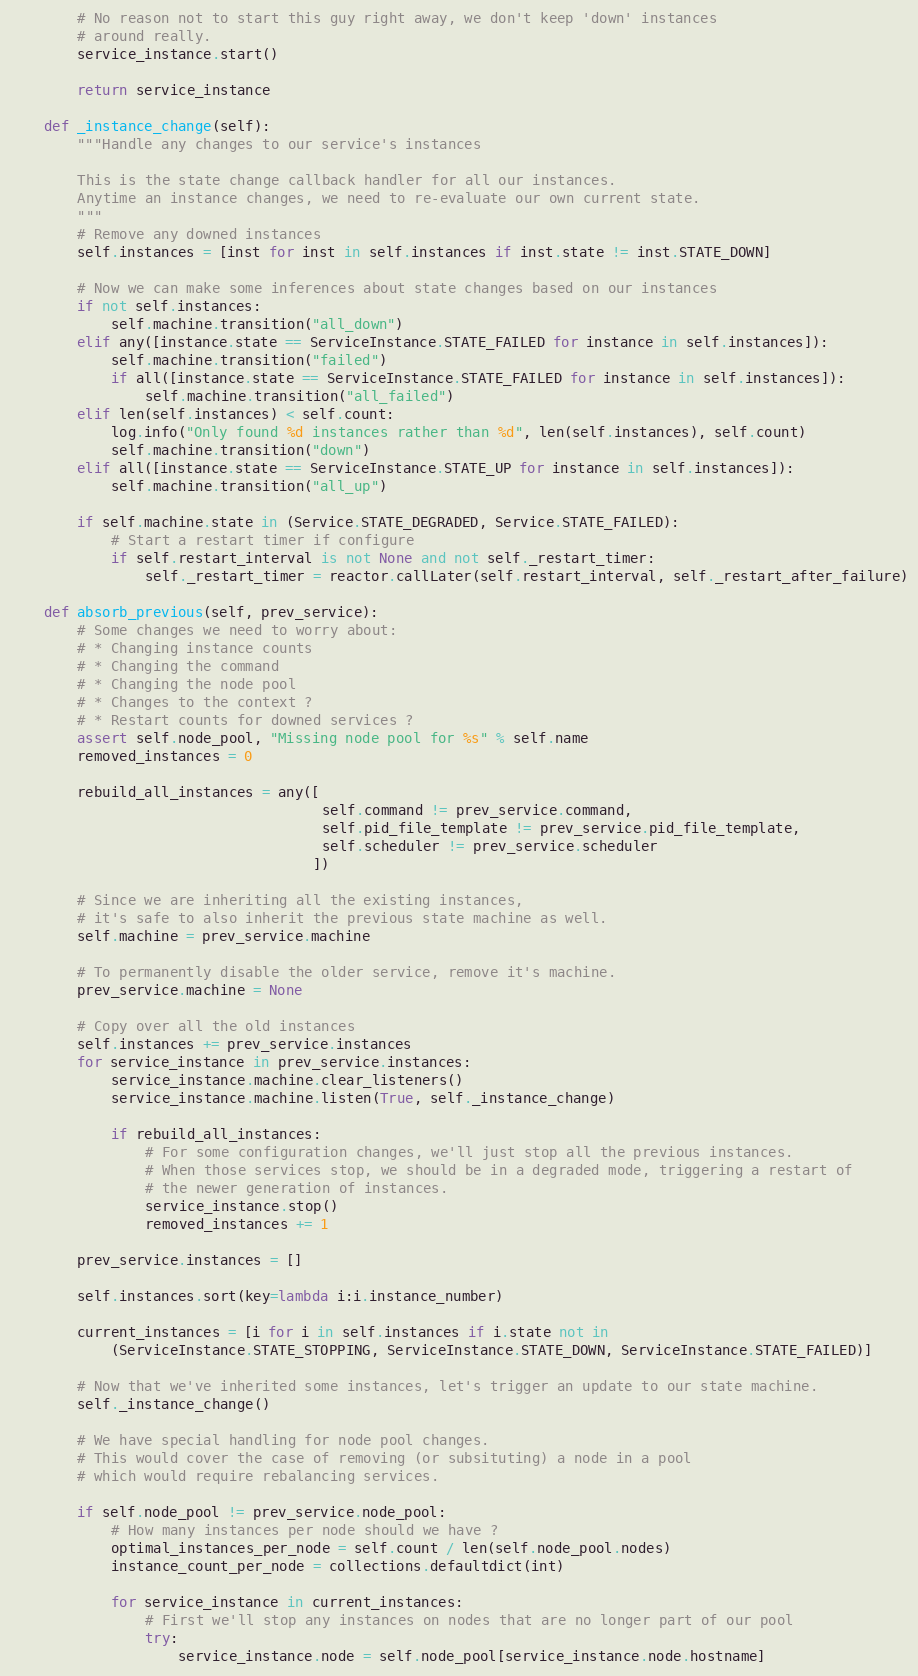<code> <loc_0><loc_0><loc_500><loc_500><_Python_>        # No reason not to start this guy right away, we don't keep 'down' instances 
        # around really.
        service_instance.start()

        return service_instance
    
    def _instance_change(self):
        """Handle any changes to our service's instances

        This is the state change callback handler for all our instances. 
        Anytime an instance changes, we need to re-evaluate our own current state.
        """
        # Remove any downed instances
        self.instances = [inst for inst in self.instances if inst.state != inst.STATE_DOWN]
        
        # Now we can make some inferences about state changes based on our instances
        if not self.instances:
            self.machine.transition("all_down")
        elif any([instance.state == ServiceInstance.STATE_FAILED for instance in self.instances]):
            self.machine.transition("failed")
            if all([instance.state == ServiceInstance.STATE_FAILED for instance in self.instances]):
                self.machine.transition("all_failed")
        elif len(self.instances) < self.count:
            log.info("Only found %d instances rather than %d", len(self.instances), self.count)
            self.machine.transition("down")
        elif all([instance.state == ServiceInstance.STATE_UP for instance in self.instances]):
            self.machine.transition("all_up")
        
        if self.machine.state in (Service.STATE_DEGRADED, Service.STATE_FAILED):
            # Start a restart timer if configure
            if self.restart_interval is not None and not self._restart_timer:
                self._restart_timer = reactor.callLater(self.restart_interval, self._restart_after_failure)

    def absorb_previous(self, prev_service):
        # Some changes we need to worry about:
        # * Changing instance counts
        # * Changing the command
        # * Changing the node pool
        # * Changes to the context ?
        # * Restart counts for downed services ?
        assert self.node_pool, "Missing node pool for %s" % self.name
        removed_instances = 0        
        
        rebuild_all_instances = any([
                                     self.command != prev_service.command,
                                     self.pid_file_template != prev_service.pid_file_template,
                                     self.scheduler != prev_service.scheduler
                                    ])
        
        # Since we are inheriting all the existing instances, 
        # it's safe to also inherit the previous state machine as well.
        self.machine = prev_service.machine

        # To permanently disable the older service, remove it's machine.
        prev_service.machine = None

        # Copy over all the old instances
        self.instances += prev_service.instances
        for service_instance in prev_service.instances:
            service_instance.machine.clear_listeners()
            service_instance.machine.listen(True, self._instance_change)
        
            if rebuild_all_instances:
                # For some configuration changes, we'll just stop all the previous instances.
                # When those services stop, we should be in a degraded mode, triggering a restart of
                # the newer generation of instances.
                service_instance.stop()
                removed_instances += 1

        prev_service.instances = []

        self.instances.sort(key=lambda i:i.instance_number)

        current_instances = [i for i in self.instances if i.state not in 
            (ServiceInstance.STATE_STOPPING, ServiceInstance.STATE_DOWN, ServiceInstance.STATE_FAILED)]

        # Now that we've inherited some instances, let's trigger an update to our state machine.
        self._instance_change()

        # We have special handling for node pool changes.
        # This would cover the case of removing (or subsituting) a node in a pool
        # which would require rebalancing services.

        if self.node_pool != prev_service.node_pool:
            # How many instances per node should we have ?
            optimal_instances_per_node = self.count / len(self.node_pool.nodes)
            instance_count_per_node = collections.defaultdict(int)

            for service_instance in current_instances:
                # First we'll stop any instances on nodes that are no longer part of our pool
                try:
                    service_instance.node = self.node_pool[service_instance.node.hostname]</code> 